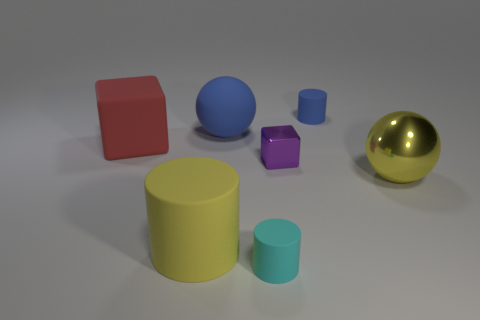Is the number of small cyan cylinders greater than the number of large brown rubber cylinders?
Your answer should be very brief. Yes. How big is the rubber object that is right of the blue matte sphere and behind the yellow cylinder?
Make the answer very short. Small. Does the cyan thing that is in front of the tiny block have the same material as the blue object that is in front of the small blue thing?
Offer a very short reply. Yes. What shape is the blue matte object that is the same size as the red object?
Make the answer very short. Sphere. Is the number of gray matte cylinders less than the number of small rubber cylinders?
Ensure brevity in your answer.  Yes. Is there a blue matte ball that is in front of the yellow thing on the left side of the big metallic ball?
Provide a short and direct response. No. There is a small cylinder on the right side of the matte cylinder that is in front of the yellow matte object; is there a big block that is in front of it?
Ensure brevity in your answer.  Yes. There is a yellow thing that is on the right side of the blue rubber cylinder; is it the same shape as the blue object that is on the left side of the tiny cyan rubber cylinder?
Make the answer very short. Yes. What is the color of the cube that is the same material as the small blue object?
Your answer should be very brief. Red. Is the number of blue spheres that are on the left side of the yellow cylinder less than the number of small blue rubber cylinders?
Ensure brevity in your answer.  Yes. 